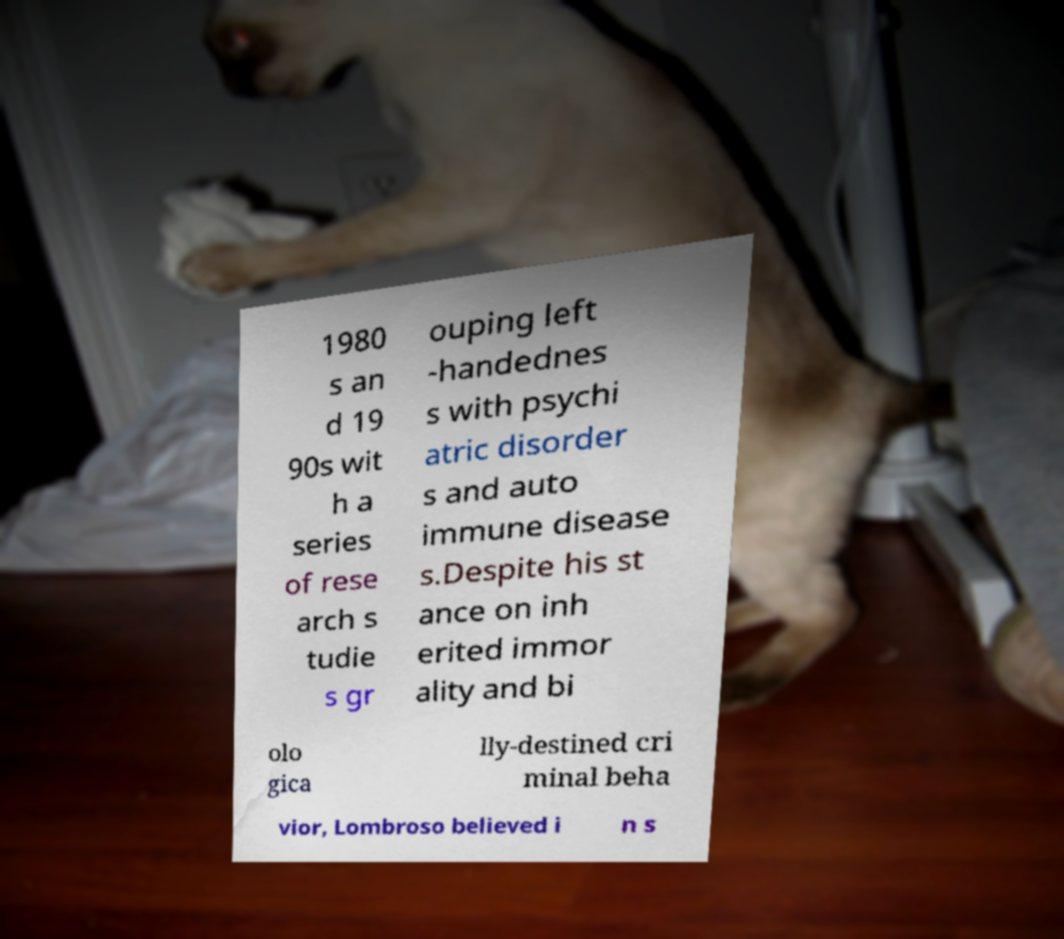For documentation purposes, I need the text within this image transcribed. Could you provide that? 1980 s an d 19 90s wit h a series of rese arch s tudie s gr ouping left -handednes s with psychi atric disorder s and auto immune disease s.Despite his st ance on inh erited immor ality and bi olo gica lly-destined cri minal beha vior, Lombroso believed i n s 